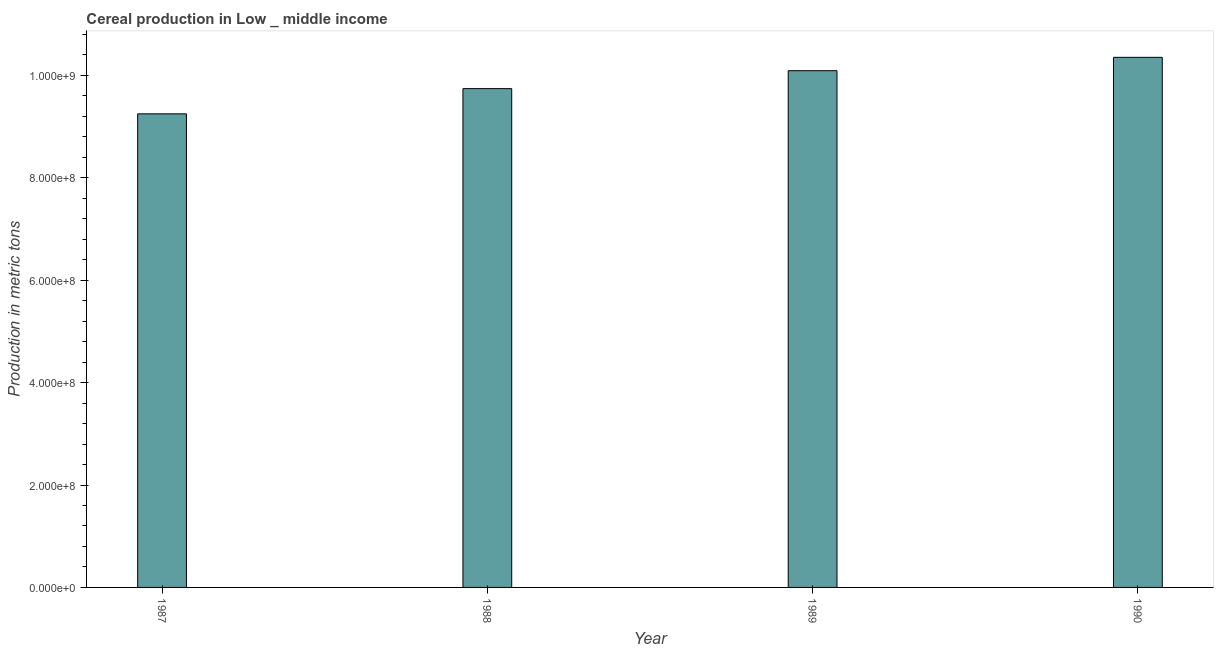Does the graph contain grids?
Your answer should be compact. No. What is the title of the graph?
Keep it short and to the point. Cereal production in Low _ middle income. What is the label or title of the X-axis?
Provide a succinct answer. Year. What is the label or title of the Y-axis?
Make the answer very short. Production in metric tons. What is the cereal production in 1989?
Give a very brief answer. 1.01e+09. Across all years, what is the maximum cereal production?
Your response must be concise. 1.04e+09. Across all years, what is the minimum cereal production?
Provide a succinct answer. 9.25e+08. What is the sum of the cereal production?
Offer a terse response. 3.94e+09. What is the difference between the cereal production in 1989 and 1990?
Your answer should be very brief. -2.61e+07. What is the average cereal production per year?
Your response must be concise. 9.86e+08. What is the median cereal production?
Your answer should be compact. 9.92e+08. Do a majority of the years between 1987 and 1988 (inclusive) have cereal production greater than 520000000 metric tons?
Your response must be concise. Yes. What is the ratio of the cereal production in 1987 to that in 1988?
Give a very brief answer. 0.95. What is the difference between the highest and the second highest cereal production?
Offer a very short reply. 2.61e+07. What is the difference between the highest and the lowest cereal production?
Your answer should be very brief. 1.10e+08. In how many years, is the cereal production greater than the average cereal production taken over all years?
Keep it short and to the point. 2. Are the values on the major ticks of Y-axis written in scientific E-notation?
Ensure brevity in your answer.  Yes. What is the Production in metric tons of 1987?
Offer a very short reply. 9.25e+08. What is the Production in metric tons in 1988?
Offer a very short reply. 9.74e+08. What is the Production in metric tons of 1989?
Provide a short and direct response. 1.01e+09. What is the Production in metric tons in 1990?
Offer a terse response. 1.04e+09. What is the difference between the Production in metric tons in 1987 and 1988?
Your answer should be compact. -4.92e+07. What is the difference between the Production in metric tons in 1987 and 1989?
Provide a short and direct response. -8.43e+07. What is the difference between the Production in metric tons in 1987 and 1990?
Give a very brief answer. -1.10e+08. What is the difference between the Production in metric tons in 1988 and 1989?
Offer a terse response. -3.50e+07. What is the difference between the Production in metric tons in 1988 and 1990?
Give a very brief answer. -6.11e+07. What is the difference between the Production in metric tons in 1989 and 1990?
Give a very brief answer. -2.61e+07. What is the ratio of the Production in metric tons in 1987 to that in 1988?
Your response must be concise. 0.95. What is the ratio of the Production in metric tons in 1987 to that in 1989?
Keep it short and to the point. 0.92. What is the ratio of the Production in metric tons in 1987 to that in 1990?
Offer a terse response. 0.89. What is the ratio of the Production in metric tons in 1988 to that in 1990?
Offer a very short reply. 0.94. 